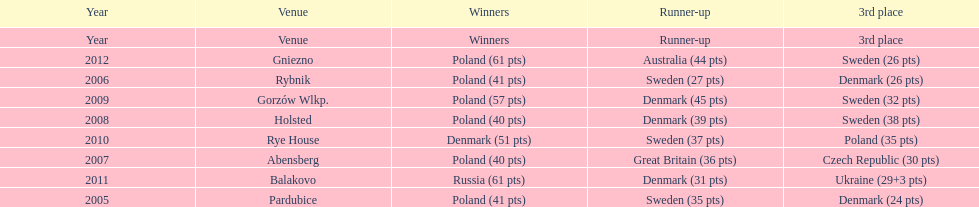From 2005-2012, in the team speedway junior world championship, how many more first place wins than all other teams put together? Poland. 